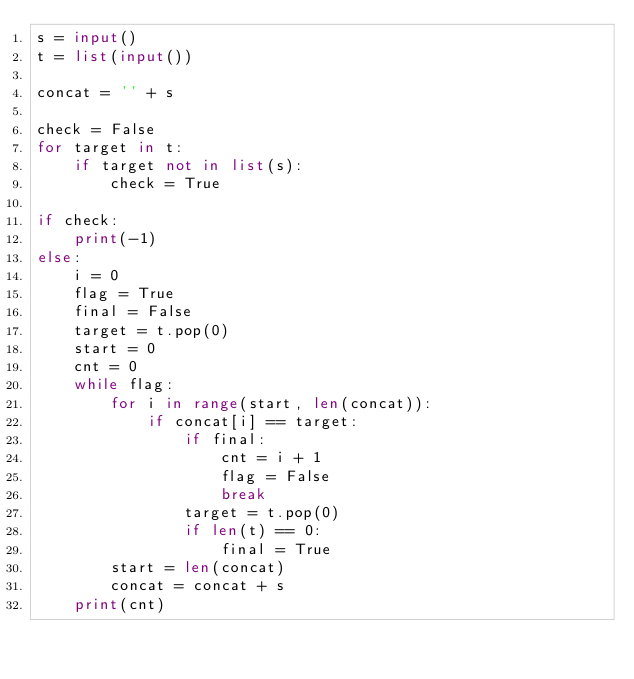<code> <loc_0><loc_0><loc_500><loc_500><_Python_>s = input()
t = list(input())

concat = '' + s

check = False
for target in t:
    if target not in list(s):
        check = True

if check:
    print(-1)
else:
    i = 0
    flag = True
    final = False
    target = t.pop(0)
    start = 0
    cnt = 0
    while flag:
        for i in range(start, len(concat)):
            if concat[i] == target:
                if final:
                    cnt = i + 1
                    flag = False
                    break
                target = t.pop(0)
                if len(t) == 0:
                    final = True
        start = len(concat)
        concat = concat + s
    print(cnt)</code> 